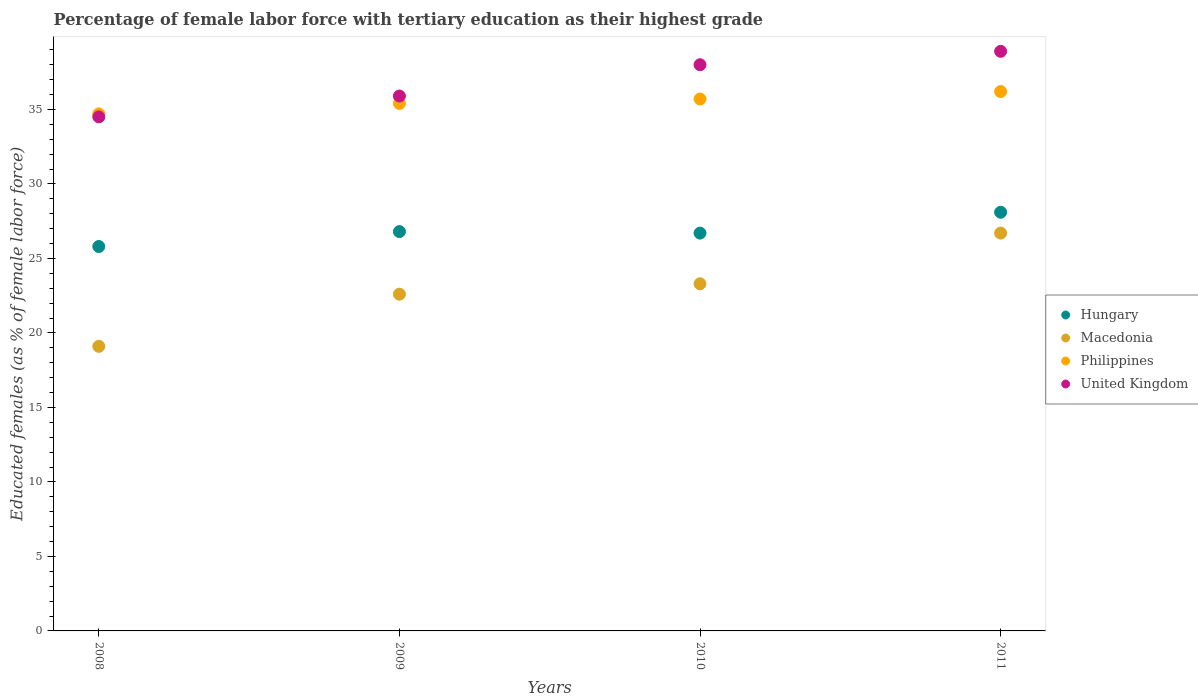Is the number of dotlines equal to the number of legend labels?
Offer a very short reply. Yes. What is the percentage of female labor force with tertiary education in Philippines in 2009?
Your response must be concise. 35.4. Across all years, what is the maximum percentage of female labor force with tertiary education in Philippines?
Your response must be concise. 36.2. Across all years, what is the minimum percentage of female labor force with tertiary education in Macedonia?
Offer a very short reply. 19.1. In which year was the percentage of female labor force with tertiary education in Hungary maximum?
Provide a succinct answer. 2011. In which year was the percentage of female labor force with tertiary education in Philippines minimum?
Offer a terse response. 2008. What is the total percentage of female labor force with tertiary education in Hungary in the graph?
Offer a terse response. 107.4. What is the difference between the percentage of female labor force with tertiary education in Macedonia in 2010 and that in 2011?
Your answer should be compact. -3.4. What is the difference between the percentage of female labor force with tertiary education in Hungary in 2011 and the percentage of female labor force with tertiary education in Philippines in 2010?
Make the answer very short. -7.6. What is the average percentage of female labor force with tertiary education in United Kingdom per year?
Give a very brief answer. 36.83. In the year 2009, what is the difference between the percentage of female labor force with tertiary education in Macedonia and percentage of female labor force with tertiary education in Philippines?
Your answer should be compact. -12.8. In how many years, is the percentage of female labor force with tertiary education in Macedonia greater than 14 %?
Offer a very short reply. 4. What is the ratio of the percentage of female labor force with tertiary education in Hungary in 2008 to that in 2010?
Keep it short and to the point. 0.97. Is the percentage of female labor force with tertiary education in United Kingdom in 2008 less than that in 2011?
Your response must be concise. Yes. What is the difference between the highest and the second highest percentage of female labor force with tertiary education in Hungary?
Make the answer very short. 1.3. What is the difference between the highest and the lowest percentage of female labor force with tertiary education in Macedonia?
Keep it short and to the point. 7.6. In how many years, is the percentage of female labor force with tertiary education in United Kingdom greater than the average percentage of female labor force with tertiary education in United Kingdom taken over all years?
Give a very brief answer. 2. Is the sum of the percentage of female labor force with tertiary education in Philippines in 2008 and 2009 greater than the maximum percentage of female labor force with tertiary education in Macedonia across all years?
Make the answer very short. Yes. Is it the case that in every year, the sum of the percentage of female labor force with tertiary education in Philippines and percentage of female labor force with tertiary education in Hungary  is greater than the sum of percentage of female labor force with tertiary education in United Kingdom and percentage of female labor force with tertiary education in Macedonia?
Keep it short and to the point. No. How many dotlines are there?
Offer a terse response. 4. How many years are there in the graph?
Give a very brief answer. 4. Are the values on the major ticks of Y-axis written in scientific E-notation?
Give a very brief answer. No. Does the graph contain any zero values?
Offer a very short reply. No. Where does the legend appear in the graph?
Provide a short and direct response. Center right. How are the legend labels stacked?
Give a very brief answer. Vertical. What is the title of the graph?
Make the answer very short. Percentage of female labor force with tertiary education as their highest grade. Does "Eritrea" appear as one of the legend labels in the graph?
Your answer should be compact. No. What is the label or title of the X-axis?
Provide a short and direct response. Years. What is the label or title of the Y-axis?
Make the answer very short. Educated females (as % of female labor force). What is the Educated females (as % of female labor force) of Hungary in 2008?
Your response must be concise. 25.8. What is the Educated females (as % of female labor force) in Macedonia in 2008?
Give a very brief answer. 19.1. What is the Educated females (as % of female labor force) of Philippines in 2008?
Your response must be concise. 34.7. What is the Educated females (as % of female labor force) in United Kingdom in 2008?
Give a very brief answer. 34.5. What is the Educated females (as % of female labor force) in Hungary in 2009?
Provide a succinct answer. 26.8. What is the Educated females (as % of female labor force) in Macedonia in 2009?
Your answer should be compact. 22.6. What is the Educated females (as % of female labor force) in Philippines in 2009?
Ensure brevity in your answer.  35.4. What is the Educated females (as % of female labor force) in United Kingdom in 2009?
Your answer should be compact. 35.9. What is the Educated females (as % of female labor force) in Hungary in 2010?
Ensure brevity in your answer.  26.7. What is the Educated females (as % of female labor force) in Macedonia in 2010?
Your response must be concise. 23.3. What is the Educated females (as % of female labor force) of Philippines in 2010?
Provide a short and direct response. 35.7. What is the Educated females (as % of female labor force) of United Kingdom in 2010?
Your answer should be very brief. 38. What is the Educated females (as % of female labor force) in Hungary in 2011?
Your answer should be very brief. 28.1. What is the Educated females (as % of female labor force) of Macedonia in 2011?
Your answer should be compact. 26.7. What is the Educated females (as % of female labor force) in Philippines in 2011?
Offer a very short reply. 36.2. What is the Educated females (as % of female labor force) in United Kingdom in 2011?
Your answer should be compact. 38.9. Across all years, what is the maximum Educated females (as % of female labor force) in Hungary?
Ensure brevity in your answer.  28.1. Across all years, what is the maximum Educated females (as % of female labor force) in Macedonia?
Offer a terse response. 26.7. Across all years, what is the maximum Educated females (as % of female labor force) of Philippines?
Keep it short and to the point. 36.2. Across all years, what is the maximum Educated females (as % of female labor force) of United Kingdom?
Your response must be concise. 38.9. Across all years, what is the minimum Educated females (as % of female labor force) in Hungary?
Give a very brief answer. 25.8. Across all years, what is the minimum Educated females (as % of female labor force) in Macedonia?
Offer a terse response. 19.1. Across all years, what is the minimum Educated females (as % of female labor force) in Philippines?
Your answer should be very brief. 34.7. Across all years, what is the minimum Educated females (as % of female labor force) in United Kingdom?
Your answer should be very brief. 34.5. What is the total Educated females (as % of female labor force) of Hungary in the graph?
Your answer should be very brief. 107.4. What is the total Educated females (as % of female labor force) of Macedonia in the graph?
Provide a short and direct response. 91.7. What is the total Educated females (as % of female labor force) of Philippines in the graph?
Your answer should be compact. 142. What is the total Educated females (as % of female labor force) of United Kingdom in the graph?
Your answer should be compact. 147.3. What is the difference between the Educated females (as % of female labor force) in Hungary in 2008 and that in 2009?
Make the answer very short. -1. What is the difference between the Educated females (as % of female labor force) in Macedonia in 2008 and that in 2009?
Provide a succinct answer. -3.5. What is the difference between the Educated females (as % of female labor force) in Philippines in 2008 and that in 2009?
Offer a very short reply. -0.7. What is the difference between the Educated females (as % of female labor force) in United Kingdom in 2008 and that in 2009?
Give a very brief answer. -1.4. What is the difference between the Educated females (as % of female labor force) in United Kingdom in 2008 and that in 2010?
Ensure brevity in your answer.  -3.5. What is the difference between the Educated females (as % of female labor force) in Hungary in 2008 and that in 2011?
Provide a short and direct response. -2.3. What is the difference between the Educated females (as % of female labor force) in Hungary in 2009 and that in 2011?
Offer a very short reply. -1.3. What is the difference between the Educated females (as % of female labor force) of Philippines in 2009 and that in 2011?
Your answer should be very brief. -0.8. What is the difference between the Educated females (as % of female labor force) in Hungary in 2010 and that in 2011?
Give a very brief answer. -1.4. What is the difference between the Educated females (as % of female labor force) in Macedonia in 2010 and that in 2011?
Ensure brevity in your answer.  -3.4. What is the difference between the Educated females (as % of female labor force) in Philippines in 2010 and that in 2011?
Your answer should be compact. -0.5. What is the difference between the Educated females (as % of female labor force) in United Kingdom in 2010 and that in 2011?
Your answer should be very brief. -0.9. What is the difference between the Educated females (as % of female labor force) in Hungary in 2008 and the Educated females (as % of female labor force) in Macedonia in 2009?
Offer a very short reply. 3.2. What is the difference between the Educated females (as % of female labor force) in Macedonia in 2008 and the Educated females (as % of female labor force) in Philippines in 2009?
Your answer should be compact. -16.3. What is the difference between the Educated females (as % of female labor force) in Macedonia in 2008 and the Educated females (as % of female labor force) in United Kingdom in 2009?
Keep it short and to the point. -16.8. What is the difference between the Educated females (as % of female labor force) of Hungary in 2008 and the Educated females (as % of female labor force) of United Kingdom in 2010?
Your answer should be very brief. -12.2. What is the difference between the Educated females (as % of female labor force) of Macedonia in 2008 and the Educated females (as % of female labor force) of Philippines in 2010?
Provide a short and direct response. -16.6. What is the difference between the Educated females (as % of female labor force) of Macedonia in 2008 and the Educated females (as % of female labor force) of United Kingdom in 2010?
Provide a short and direct response. -18.9. What is the difference between the Educated females (as % of female labor force) of Hungary in 2008 and the Educated females (as % of female labor force) of United Kingdom in 2011?
Your answer should be compact. -13.1. What is the difference between the Educated females (as % of female labor force) of Macedonia in 2008 and the Educated females (as % of female labor force) of Philippines in 2011?
Ensure brevity in your answer.  -17.1. What is the difference between the Educated females (as % of female labor force) in Macedonia in 2008 and the Educated females (as % of female labor force) in United Kingdom in 2011?
Provide a short and direct response. -19.8. What is the difference between the Educated females (as % of female labor force) in Philippines in 2008 and the Educated females (as % of female labor force) in United Kingdom in 2011?
Provide a succinct answer. -4.2. What is the difference between the Educated females (as % of female labor force) in Hungary in 2009 and the Educated females (as % of female labor force) in Macedonia in 2010?
Your answer should be very brief. 3.5. What is the difference between the Educated females (as % of female labor force) in Hungary in 2009 and the Educated females (as % of female labor force) in Philippines in 2010?
Provide a succinct answer. -8.9. What is the difference between the Educated females (as % of female labor force) in Macedonia in 2009 and the Educated females (as % of female labor force) in United Kingdom in 2010?
Your answer should be compact. -15.4. What is the difference between the Educated females (as % of female labor force) of Philippines in 2009 and the Educated females (as % of female labor force) of United Kingdom in 2010?
Keep it short and to the point. -2.6. What is the difference between the Educated females (as % of female labor force) in Hungary in 2009 and the Educated females (as % of female labor force) in Philippines in 2011?
Your response must be concise. -9.4. What is the difference between the Educated females (as % of female labor force) of Hungary in 2009 and the Educated females (as % of female labor force) of United Kingdom in 2011?
Provide a succinct answer. -12.1. What is the difference between the Educated females (as % of female labor force) of Macedonia in 2009 and the Educated females (as % of female labor force) of United Kingdom in 2011?
Your response must be concise. -16.3. What is the difference between the Educated females (as % of female labor force) of Hungary in 2010 and the Educated females (as % of female labor force) of Macedonia in 2011?
Ensure brevity in your answer.  0. What is the difference between the Educated females (as % of female labor force) in Macedonia in 2010 and the Educated females (as % of female labor force) in United Kingdom in 2011?
Provide a short and direct response. -15.6. What is the average Educated females (as % of female labor force) in Hungary per year?
Provide a short and direct response. 26.85. What is the average Educated females (as % of female labor force) of Macedonia per year?
Your answer should be very brief. 22.93. What is the average Educated females (as % of female labor force) in Philippines per year?
Offer a terse response. 35.5. What is the average Educated females (as % of female labor force) of United Kingdom per year?
Make the answer very short. 36.83. In the year 2008, what is the difference between the Educated females (as % of female labor force) of Hungary and Educated females (as % of female labor force) of Philippines?
Your answer should be compact. -8.9. In the year 2008, what is the difference between the Educated females (as % of female labor force) of Hungary and Educated females (as % of female labor force) of United Kingdom?
Offer a terse response. -8.7. In the year 2008, what is the difference between the Educated females (as % of female labor force) in Macedonia and Educated females (as % of female labor force) in Philippines?
Offer a very short reply. -15.6. In the year 2008, what is the difference between the Educated females (as % of female labor force) in Macedonia and Educated females (as % of female labor force) in United Kingdom?
Your answer should be compact. -15.4. In the year 2009, what is the difference between the Educated females (as % of female labor force) in Hungary and Educated females (as % of female labor force) in Macedonia?
Your response must be concise. 4.2. In the year 2009, what is the difference between the Educated females (as % of female labor force) in Hungary and Educated females (as % of female labor force) in Philippines?
Make the answer very short. -8.6. In the year 2009, what is the difference between the Educated females (as % of female labor force) of Macedonia and Educated females (as % of female labor force) of Philippines?
Provide a short and direct response. -12.8. In the year 2010, what is the difference between the Educated females (as % of female labor force) of Hungary and Educated females (as % of female labor force) of Macedonia?
Offer a very short reply. 3.4. In the year 2010, what is the difference between the Educated females (as % of female labor force) in Hungary and Educated females (as % of female labor force) in Philippines?
Provide a short and direct response. -9. In the year 2010, what is the difference between the Educated females (as % of female labor force) of Hungary and Educated females (as % of female labor force) of United Kingdom?
Make the answer very short. -11.3. In the year 2010, what is the difference between the Educated females (as % of female labor force) in Macedonia and Educated females (as % of female labor force) in Philippines?
Your answer should be very brief. -12.4. In the year 2010, what is the difference between the Educated females (as % of female labor force) in Macedonia and Educated females (as % of female labor force) in United Kingdom?
Make the answer very short. -14.7. In the year 2011, what is the difference between the Educated females (as % of female labor force) in Hungary and Educated females (as % of female labor force) in Macedonia?
Your answer should be compact. 1.4. In the year 2011, what is the difference between the Educated females (as % of female labor force) of Macedonia and Educated females (as % of female labor force) of United Kingdom?
Your answer should be very brief. -12.2. In the year 2011, what is the difference between the Educated females (as % of female labor force) in Philippines and Educated females (as % of female labor force) in United Kingdom?
Offer a very short reply. -2.7. What is the ratio of the Educated females (as % of female labor force) of Hungary in 2008 to that in 2009?
Ensure brevity in your answer.  0.96. What is the ratio of the Educated females (as % of female labor force) of Macedonia in 2008 to that in 2009?
Your answer should be compact. 0.85. What is the ratio of the Educated females (as % of female labor force) of Philippines in 2008 to that in 2009?
Provide a short and direct response. 0.98. What is the ratio of the Educated females (as % of female labor force) of Hungary in 2008 to that in 2010?
Offer a terse response. 0.97. What is the ratio of the Educated females (as % of female labor force) in Macedonia in 2008 to that in 2010?
Provide a succinct answer. 0.82. What is the ratio of the Educated females (as % of female labor force) in Philippines in 2008 to that in 2010?
Ensure brevity in your answer.  0.97. What is the ratio of the Educated females (as % of female labor force) in United Kingdom in 2008 to that in 2010?
Keep it short and to the point. 0.91. What is the ratio of the Educated females (as % of female labor force) of Hungary in 2008 to that in 2011?
Offer a very short reply. 0.92. What is the ratio of the Educated females (as % of female labor force) in Macedonia in 2008 to that in 2011?
Keep it short and to the point. 0.72. What is the ratio of the Educated females (as % of female labor force) in Philippines in 2008 to that in 2011?
Make the answer very short. 0.96. What is the ratio of the Educated females (as % of female labor force) in United Kingdom in 2008 to that in 2011?
Provide a short and direct response. 0.89. What is the ratio of the Educated females (as % of female labor force) of Philippines in 2009 to that in 2010?
Offer a terse response. 0.99. What is the ratio of the Educated females (as % of female labor force) in United Kingdom in 2009 to that in 2010?
Give a very brief answer. 0.94. What is the ratio of the Educated females (as % of female labor force) in Hungary in 2009 to that in 2011?
Make the answer very short. 0.95. What is the ratio of the Educated females (as % of female labor force) in Macedonia in 2009 to that in 2011?
Provide a short and direct response. 0.85. What is the ratio of the Educated females (as % of female labor force) in Philippines in 2009 to that in 2011?
Keep it short and to the point. 0.98. What is the ratio of the Educated females (as % of female labor force) in United Kingdom in 2009 to that in 2011?
Keep it short and to the point. 0.92. What is the ratio of the Educated females (as % of female labor force) of Hungary in 2010 to that in 2011?
Keep it short and to the point. 0.95. What is the ratio of the Educated females (as % of female labor force) of Macedonia in 2010 to that in 2011?
Your answer should be compact. 0.87. What is the ratio of the Educated females (as % of female labor force) in Philippines in 2010 to that in 2011?
Ensure brevity in your answer.  0.99. What is the ratio of the Educated females (as % of female labor force) of United Kingdom in 2010 to that in 2011?
Make the answer very short. 0.98. What is the difference between the highest and the second highest Educated females (as % of female labor force) of Hungary?
Your answer should be compact. 1.3. What is the difference between the highest and the second highest Educated females (as % of female labor force) of Macedonia?
Ensure brevity in your answer.  3.4. What is the difference between the highest and the second highest Educated females (as % of female labor force) in United Kingdom?
Offer a terse response. 0.9. What is the difference between the highest and the lowest Educated females (as % of female labor force) of Hungary?
Make the answer very short. 2.3. 